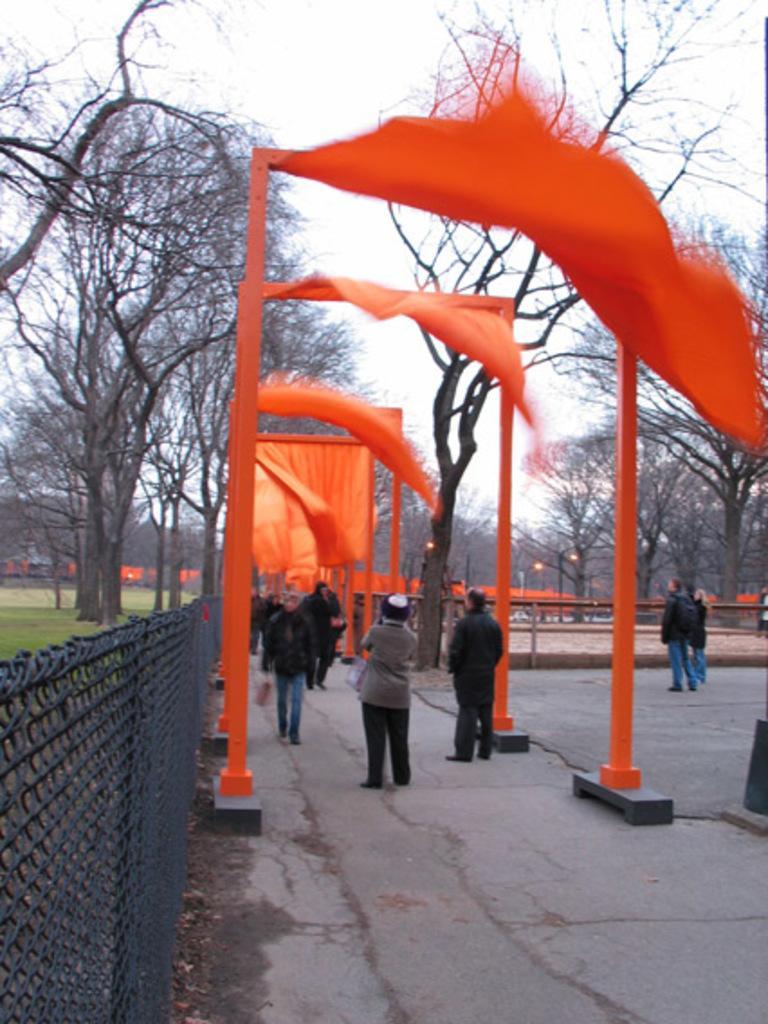How would you summarize this image in a sentence or two? In this image, we can see some people standing and there are some people walking, at the left side there is a black color fencing, we can see some trees, at the top there is a sky. 